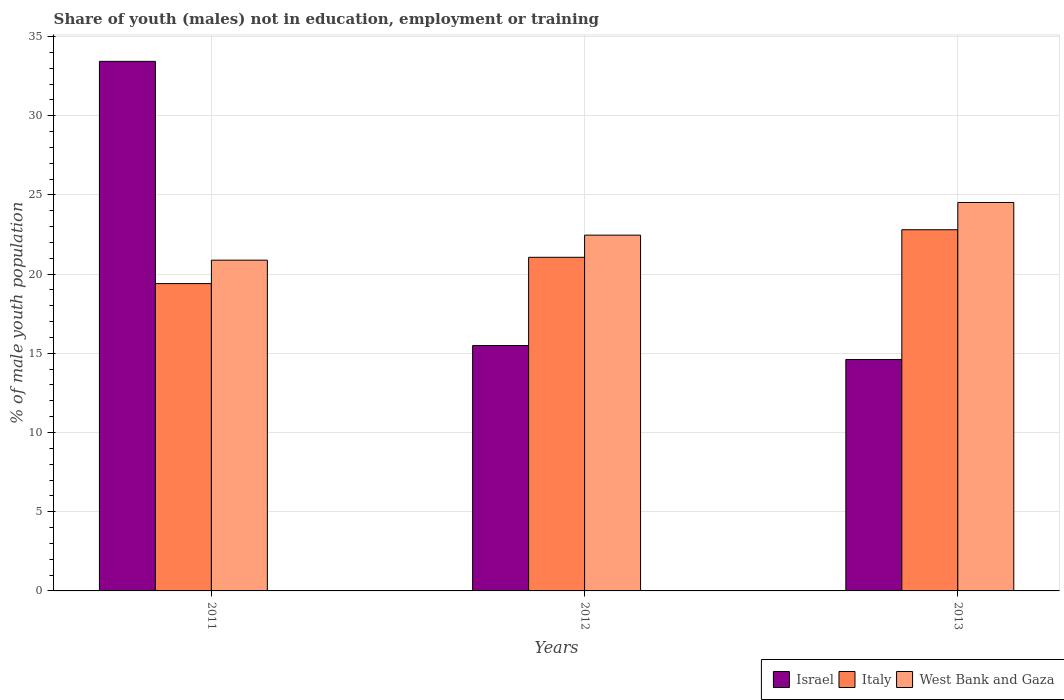Are the number of bars per tick equal to the number of legend labels?
Provide a succinct answer. Yes. Are the number of bars on each tick of the X-axis equal?
Provide a short and direct response. Yes. How many bars are there on the 1st tick from the left?
Keep it short and to the point. 3. In how many cases, is the number of bars for a given year not equal to the number of legend labels?
Ensure brevity in your answer.  0. What is the percentage of unemployed males population in in West Bank and Gaza in 2012?
Make the answer very short. 22.46. Across all years, what is the maximum percentage of unemployed males population in in Israel?
Your answer should be compact. 33.43. Across all years, what is the minimum percentage of unemployed males population in in West Bank and Gaza?
Your answer should be very brief. 20.88. What is the total percentage of unemployed males population in in Italy in the graph?
Make the answer very short. 63.26. What is the difference between the percentage of unemployed males population in in West Bank and Gaza in 2011 and that in 2013?
Give a very brief answer. -3.64. What is the difference between the percentage of unemployed males population in in Israel in 2011 and the percentage of unemployed males population in in West Bank and Gaza in 2012?
Give a very brief answer. 10.97. What is the average percentage of unemployed males population in in West Bank and Gaza per year?
Your answer should be very brief. 22.62. In the year 2013, what is the difference between the percentage of unemployed males population in in West Bank and Gaza and percentage of unemployed males population in in Italy?
Your response must be concise. 1.72. In how many years, is the percentage of unemployed males population in in Italy greater than 10 %?
Your answer should be very brief. 3. What is the ratio of the percentage of unemployed males population in in Italy in 2012 to that in 2013?
Provide a succinct answer. 0.92. Is the percentage of unemployed males population in in West Bank and Gaza in 2011 less than that in 2012?
Your answer should be very brief. Yes. Is the difference between the percentage of unemployed males population in in West Bank and Gaza in 2011 and 2012 greater than the difference between the percentage of unemployed males population in in Italy in 2011 and 2012?
Ensure brevity in your answer.  Yes. What is the difference between the highest and the second highest percentage of unemployed males population in in West Bank and Gaza?
Your response must be concise. 2.06. What is the difference between the highest and the lowest percentage of unemployed males population in in Israel?
Keep it short and to the point. 18.82. In how many years, is the percentage of unemployed males population in in Israel greater than the average percentage of unemployed males population in in Israel taken over all years?
Offer a very short reply. 1. What does the 3rd bar from the right in 2012 represents?
Your response must be concise. Israel. Are all the bars in the graph horizontal?
Provide a succinct answer. No. How many years are there in the graph?
Provide a succinct answer. 3. What is the difference between two consecutive major ticks on the Y-axis?
Offer a terse response. 5. Does the graph contain any zero values?
Provide a succinct answer. No. Does the graph contain grids?
Make the answer very short. Yes. Where does the legend appear in the graph?
Give a very brief answer. Bottom right. How are the legend labels stacked?
Your answer should be very brief. Horizontal. What is the title of the graph?
Ensure brevity in your answer.  Share of youth (males) not in education, employment or training. Does "Fragile and conflict affected situations" appear as one of the legend labels in the graph?
Provide a succinct answer. No. What is the label or title of the X-axis?
Make the answer very short. Years. What is the label or title of the Y-axis?
Keep it short and to the point. % of male youth population. What is the % of male youth population of Israel in 2011?
Give a very brief answer. 33.43. What is the % of male youth population of Italy in 2011?
Your response must be concise. 19.4. What is the % of male youth population in West Bank and Gaza in 2011?
Keep it short and to the point. 20.88. What is the % of male youth population in Israel in 2012?
Provide a succinct answer. 15.49. What is the % of male youth population in Italy in 2012?
Offer a terse response. 21.06. What is the % of male youth population in West Bank and Gaza in 2012?
Give a very brief answer. 22.46. What is the % of male youth population in Israel in 2013?
Keep it short and to the point. 14.61. What is the % of male youth population of Italy in 2013?
Give a very brief answer. 22.8. What is the % of male youth population of West Bank and Gaza in 2013?
Offer a terse response. 24.52. Across all years, what is the maximum % of male youth population of Israel?
Offer a terse response. 33.43. Across all years, what is the maximum % of male youth population of Italy?
Offer a terse response. 22.8. Across all years, what is the maximum % of male youth population of West Bank and Gaza?
Provide a short and direct response. 24.52. Across all years, what is the minimum % of male youth population of Israel?
Give a very brief answer. 14.61. Across all years, what is the minimum % of male youth population in Italy?
Your response must be concise. 19.4. Across all years, what is the minimum % of male youth population in West Bank and Gaza?
Give a very brief answer. 20.88. What is the total % of male youth population of Israel in the graph?
Keep it short and to the point. 63.53. What is the total % of male youth population of Italy in the graph?
Provide a short and direct response. 63.26. What is the total % of male youth population of West Bank and Gaza in the graph?
Offer a very short reply. 67.86. What is the difference between the % of male youth population of Israel in 2011 and that in 2012?
Provide a short and direct response. 17.94. What is the difference between the % of male youth population of Italy in 2011 and that in 2012?
Give a very brief answer. -1.66. What is the difference between the % of male youth population in West Bank and Gaza in 2011 and that in 2012?
Provide a short and direct response. -1.58. What is the difference between the % of male youth population of Israel in 2011 and that in 2013?
Offer a very short reply. 18.82. What is the difference between the % of male youth population in West Bank and Gaza in 2011 and that in 2013?
Give a very brief answer. -3.64. What is the difference between the % of male youth population in Italy in 2012 and that in 2013?
Give a very brief answer. -1.74. What is the difference between the % of male youth population in West Bank and Gaza in 2012 and that in 2013?
Keep it short and to the point. -2.06. What is the difference between the % of male youth population of Israel in 2011 and the % of male youth population of Italy in 2012?
Make the answer very short. 12.37. What is the difference between the % of male youth population in Israel in 2011 and the % of male youth population in West Bank and Gaza in 2012?
Make the answer very short. 10.97. What is the difference between the % of male youth population of Italy in 2011 and the % of male youth population of West Bank and Gaza in 2012?
Make the answer very short. -3.06. What is the difference between the % of male youth population in Israel in 2011 and the % of male youth population in Italy in 2013?
Offer a terse response. 10.63. What is the difference between the % of male youth population in Israel in 2011 and the % of male youth population in West Bank and Gaza in 2013?
Your answer should be very brief. 8.91. What is the difference between the % of male youth population in Italy in 2011 and the % of male youth population in West Bank and Gaza in 2013?
Your answer should be compact. -5.12. What is the difference between the % of male youth population of Israel in 2012 and the % of male youth population of Italy in 2013?
Offer a very short reply. -7.31. What is the difference between the % of male youth population in Israel in 2012 and the % of male youth population in West Bank and Gaza in 2013?
Your response must be concise. -9.03. What is the difference between the % of male youth population of Italy in 2012 and the % of male youth population of West Bank and Gaza in 2013?
Make the answer very short. -3.46. What is the average % of male youth population of Israel per year?
Make the answer very short. 21.18. What is the average % of male youth population in Italy per year?
Give a very brief answer. 21.09. What is the average % of male youth population in West Bank and Gaza per year?
Give a very brief answer. 22.62. In the year 2011, what is the difference between the % of male youth population of Israel and % of male youth population of Italy?
Provide a short and direct response. 14.03. In the year 2011, what is the difference between the % of male youth population in Israel and % of male youth population in West Bank and Gaza?
Keep it short and to the point. 12.55. In the year 2011, what is the difference between the % of male youth population of Italy and % of male youth population of West Bank and Gaza?
Offer a very short reply. -1.48. In the year 2012, what is the difference between the % of male youth population of Israel and % of male youth population of Italy?
Make the answer very short. -5.57. In the year 2012, what is the difference between the % of male youth population of Israel and % of male youth population of West Bank and Gaza?
Offer a very short reply. -6.97. In the year 2012, what is the difference between the % of male youth population of Italy and % of male youth population of West Bank and Gaza?
Provide a short and direct response. -1.4. In the year 2013, what is the difference between the % of male youth population of Israel and % of male youth population of Italy?
Offer a terse response. -8.19. In the year 2013, what is the difference between the % of male youth population of Israel and % of male youth population of West Bank and Gaza?
Provide a succinct answer. -9.91. In the year 2013, what is the difference between the % of male youth population of Italy and % of male youth population of West Bank and Gaza?
Your response must be concise. -1.72. What is the ratio of the % of male youth population of Israel in 2011 to that in 2012?
Your answer should be very brief. 2.16. What is the ratio of the % of male youth population in Italy in 2011 to that in 2012?
Give a very brief answer. 0.92. What is the ratio of the % of male youth population in West Bank and Gaza in 2011 to that in 2012?
Offer a very short reply. 0.93. What is the ratio of the % of male youth population in Israel in 2011 to that in 2013?
Give a very brief answer. 2.29. What is the ratio of the % of male youth population of Italy in 2011 to that in 2013?
Make the answer very short. 0.85. What is the ratio of the % of male youth population of West Bank and Gaza in 2011 to that in 2013?
Make the answer very short. 0.85. What is the ratio of the % of male youth population in Israel in 2012 to that in 2013?
Your response must be concise. 1.06. What is the ratio of the % of male youth population of Italy in 2012 to that in 2013?
Your answer should be compact. 0.92. What is the ratio of the % of male youth population of West Bank and Gaza in 2012 to that in 2013?
Offer a very short reply. 0.92. What is the difference between the highest and the second highest % of male youth population in Israel?
Keep it short and to the point. 17.94. What is the difference between the highest and the second highest % of male youth population of Italy?
Your answer should be very brief. 1.74. What is the difference between the highest and the second highest % of male youth population of West Bank and Gaza?
Your response must be concise. 2.06. What is the difference between the highest and the lowest % of male youth population in Israel?
Make the answer very short. 18.82. What is the difference between the highest and the lowest % of male youth population in West Bank and Gaza?
Keep it short and to the point. 3.64. 